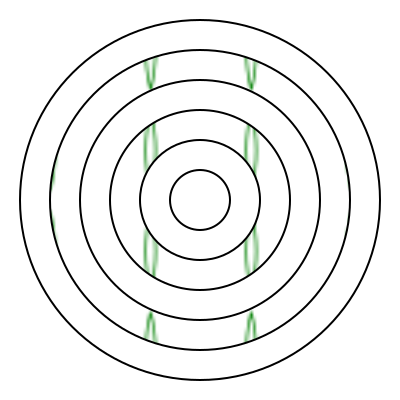In this nature-inspired mandala design, what fundamental principle of art therapy is represented by the alternating pattern of leaf-filled and white circles? To answer this question, let's analyze the mandala design step-by-step:

1. Observe the overall structure: The mandala consists of concentric circles.

2. Notice the alternating pattern: The circles alternate between leaf-filled and white spaces.

3. Recognize the symbolism:
   a) Leaf-filled circles represent nature, growth, and organic forms.
   b) White circles represent space, clarity, and potential.

4. Understand the rhythm: The alternating pattern creates a visual rhythm.

5. Relate to art therapy principles:
   a) Balance: The design shows equilibrium between filled and empty spaces.
   b) Repetition: The leaf pattern and alternating circles repeat throughout.
   c) Harmony: The elements work together to create a cohesive whole.

6. Identify the key principle: The alternating pattern most strongly represents the concept of "balance" in art therapy.

7. Connect to mental health: Balance is crucial in mental health, symbolizing the equilibrium between different aspects of life or emotions.

Therefore, the fundamental principle of art therapy represented by this alternating pattern is balance.
Answer: Balance 